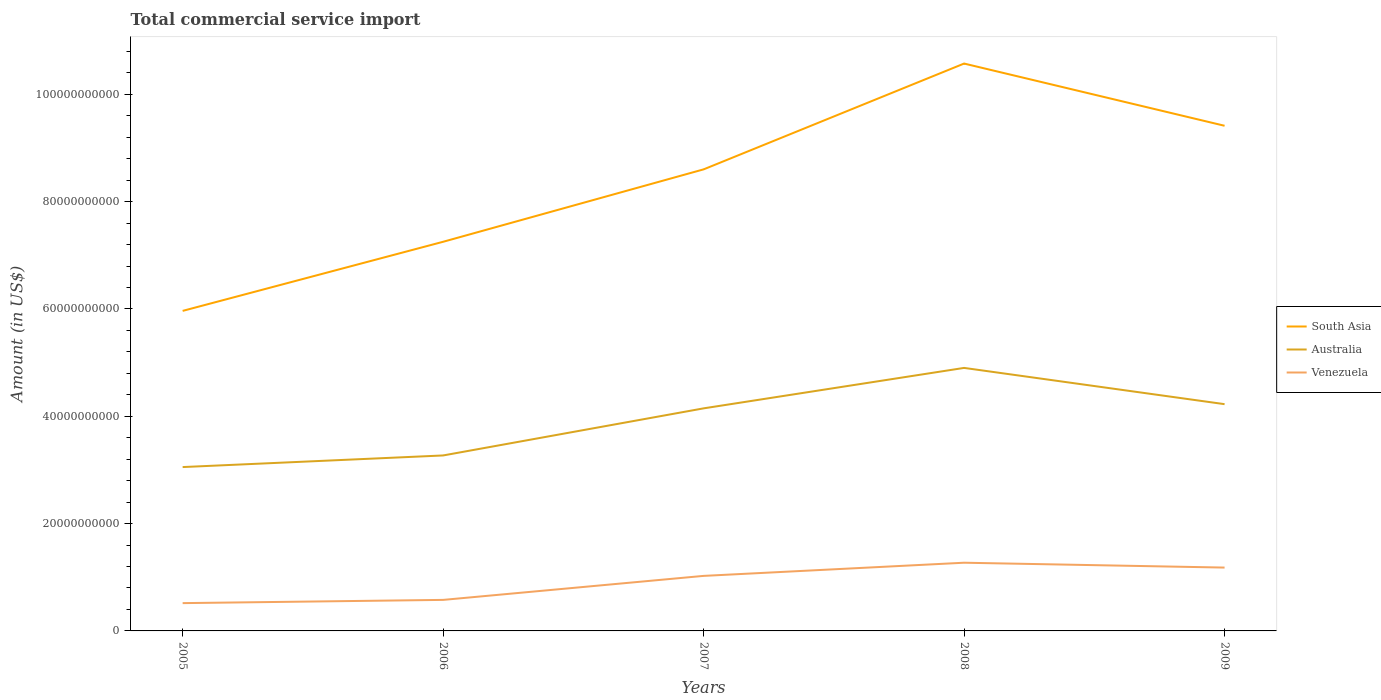How many different coloured lines are there?
Provide a short and direct response. 3. Is the number of lines equal to the number of legend labels?
Provide a succinct answer. Yes. Across all years, what is the maximum total commercial service import in Venezuela?
Give a very brief answer. 5.18e+09. What is the total total commercial service import in Venezuela in the graph?
Provide a short and direct response. -6.03e+08. What is the difference between the highest and the second highest total commercial service import in Venezuela?
Ensure brevity in your answer.  7.53e+09. How many lines are there?
Give a very brief answer. 3. Are the values on the major ticks of Y-axis written in scientific E-notation?
Your answer should be very brief. No. Where does the legend appear in the graph?
Your answer should be compact. Center right. What is the title of the graph?
Provide a short and direct response. Total commercial service import. What is the Amount (in US$) in South Asia in 2005?
Make the answer very short. 5.96e+1. What is the Amount (in US$) in Australia in 2005?
Provide a succinct answer. 3.05e+1. What is the Amount (in US$) of Venezuela in 2005?
Provide a succinct answer. 5.18e+09. What is the Amount (in US$) in South Asia in 2006?
Provide a succinct answer. 7.25e+1. What is the Amount (in US$) in Australia in 2006?
Make the answer very short. 3.27e+1. What is the Amount (in US$) in Venezuela in 2006?
Make the answer very short. 5.78e+09. What is the Amount (in US$) in South Asia in 2007?
Ensure brevity in your answer.  8.60e+1. What is the Amount (in US$) of Australia in 2007?
Your response must be concise. 4.15e+1. What is the Amount (in US$) of Venezuela in 2007?
Make the answer very short. 1.03e+1. What is the Amount (in US$) in South Asia in 2008?
Ensure brevity in your answer.  1.06e+11. What is the Amount (in US$) of Australia in 2008?
Your answer should be very brief. 4.90e+1. What is the Amount (in US$) of Venezuela in 2008?
Provide a succinct answer. 1.27e+1. What is the Amount (in US$) in South Asia in 2009?
Your answer should be compact. 9.41e+1. What is the Amount (in US$) of Australia in 2009?
Your response must be concise. 4.23e+1. What is the Amount (in US$) in Venezuela in 2009?
Keep it short and to the point. 1.18e+1. Across all years, what is the maximum Amount (in US$) of South Asia?
Your answer should be very brief. 1.06e+11. Across all years, what is the maximum Amount (in US$) in Australia?
Provide a short and direct response. 4.90e+1. Across all years, what is the maximum Amount (in US$) of Venezuela?
Your answer should be compact. 1.27e+1. Across all years, what is the minimum Amount (in US$) of South Asia?
Offer a very short reply. 5.96e+1. Across all years, what is the minimum Amount (in US$) in Australia?
Your answer should be compact. 3.05e+1. Across all years, what is the minimum Amount (in US$) in Venezuela?
Your answer should be very brief. 5.18e+09. What is the total Amount (in US$) in South Asia in the graph?
Offer a terse response. 4.18e+11. What is the total Amount (in US$) in Australia in the graph?
Your answer should be compact. 1.96e+11. What is the total Amount (in US$) in Venezuela in the graph?
Give a very brief answer. 4.57e+1. What is the difference between the Amount (in US$) of South Asia in 2005 and that in 2006?
Your response must be concise. -1.29e+1. What is the difference between the Amount (in US$) in Australia in 2005 and that in 2006?
Your answer should be very brief. -2.17e+09. What is the difference between the Amount (in US$) in Venezuela in 2005 and that in 2006?
Give a very brief answer. -6.03e+08. What is the difference between the Amount (in US$) in South Asia in 2005 and that in 2007?
Your answer should be very brief. -2.64e+1. What is the difference between the Amount (in US$) in Australia in 2005 and that in 2007?
Your answer should be compact. -1.09e+1. What is the difference between the Amount (in US$) of Venezuela in 2005 and that in 2007?
Your answer should be compact. -5.08e+09. What is the difference between the Amount (in US$) in South Asia in 2005 and that in 2008?
Provide a short and direct response. -4.61e+1. What is the difference between the Amount (in US$) in Australia in 2005 and that in 2008?
Your response must be concise. -1.85e+1. What is the difference between the Amount (in US$) of Venezuela in 2005 and that in 2008?
Make the answer very short. -7.53e+09. What is the difference between the Amount (in US$) in South Asia in 2005 and that in 2009?
Provide a short and direct response. -3.45e+1. What is the difference between the Amount (in US$) in Australia in 2005 and that in 2009?
Your response must be concise. -1.17e+1. What is the difference between the Amount (in US$) of Venezuela in 2005 and that in 2009?
Offer a terse response. -6.62e+09. What is the difference between the Amount (in US$) in South Asia in 2006 and that in 2007?
Your answer should be compact. -1.35e+1. What is the difference between the Amount (in US$) in Australia in 2006 and that in 2007?
Offer a terse response. -8.78e+09. What is the difference between the Amount (in US$) in Venezuela in 2006 and that in 2007?
Your answer should be compact. -4.47e+09. What is the difference between the Amount (in US$) in South Asia in 2006 and that in 2008?
Offer a terse response. -3.32e+1. What is the difference between the Amount (in US$) in Australia in 2006 and that in 2008?
Offer a terse response. -1.63e+1. What is the difference between the Amount (in US$) of Venezuela in 2006 and that in 2008?
Make the answer very short. -6.93e+09. What is the difference between the Amount (in US$) in South Asia in 2006 and that in 2009?
Offer a very short reply. -2.16e+1. What is the difference between the Amount (in US$) of Australia in 2006 and that in 2009?
Ensure brevity in your answer.  -9.56e+09. What is the difference between the Amount (in US$) of Venezuela in 2006 and that in 2009?
Offer a terse response. -6.02e+09. What is the difference between the Amount (in US$) in South Asia in 2007 and that in 2008?
Provide a succinct answer. -1.97e+1. What is the difference between the Amount (in US$) of Australia in 2007 and that in 2008?
Provide a succinct answer. -7.54e+09. What is the difference between the Amount (in US$) of Venezuela in 2007 and that in 2008?
Provide a succinct answer. -2.45e+09. What is the difference between the Amount (in US$) of South Asia in 2007 and that in 2009?
Offer a very short reply. -8.12e+09. What is the difference between the Amount (in US$) of Australia in 2007 and that in 2009?
Keep it short and to the point. -7.81e+08. What is the difference between the Amount (in US$) in Venezuela in 2007 and that in 2009?
Keep it short and to the point. -1.55e+09. What is the difference between the Amount (in US$) of South Asia in 2008 and that in 2009?
Your response must be concise. 1.16e+1. What is the difference between the Amount (in US$) of Australia in 2008 and that in 2009?
Your answer should be very brief. 6.76e+09. What is the difference between the Amount (in US$) in Venezuela in 2008 and that in 2009?
Provide a short and direct response. 9.05e+08. What is the difference between the Amount (in US$) of South Asia in 2005 and the Amount (in US$) of Australia in 2006?
Provide a short and direct response. 2.69e+1. What is the difference between the Amount (in US$) of South Asia in 2005 and the Amount (in US$) of Venezuela in 2006?
Your response must be concise. 5.39e+1. What is the difference between the Amount (in US$) of Australia in 2005 and the Amount (in US$) of Venezuela in 2006?
Your answer should be compact. 2.48e+1. What is the difference between the Amount (in US$) in South Asia in 2005 and the Amount (in US$) in Australia in 2007?
Make the answer very short. 1.82e+1. What is the difference between the Amount (in US$) in South Asia in 2005 and the Amount (in US$) in Venezuela in 2007?
Give a very brief answer. 4.94e+1. What is the difference between the Amount (in US$) in Australia in 2005 and the Amount (in US$) in Venezuela in 2007?
Your answer should be compact. 2.03e+1. What is the difference between the Amount (in US$) of South Asia in 2005 and the Amount (in US$) of Australia in 2008?
Keep it short and to the point. 1.06e+1. What is the difference between the Amount (in US$) in South Asia in 2005 and the Amount (in US$) in Venezuela in 2008?
Provide a short and direct response. 4.69e+1. What is the difference between the Amount (in US$) in Australia in 2005 and the Amount (in US$) in Venezuela in 2008?
Ensure brevity in your answer.  1.78e+1. What is the difference between the Amount (in US$) of South Asia in 2005 and the Amount (in US$) of Australia in 2009?
Provide a succinct answer. 1.74e+1. What is the difference between the Amount (in US$) of South Asia in 2005 and the Amount (in US$) of Venezuela in 2009?
Give a very brief answer. 4.78e+1. What is the difference between the Amount (in US$) of Australia in 2005 and the Amount (in US$) of Venezuela in 2009?
Your response must be concise. 1.87e+1. What is the difference between the Amount (in US$) of South Asia in 2006 and the Amount (in US$) of Australia in 2007?
Your answer should be compact. 3.10e+1. What is the difference between the Amount (in US$) in South Asia in 2006 and the Amount (in US$) in Venezuela in 2007?
Give a very brief answer. 6.23e+1. What is the difference between the Amount (in US$) in Australia in 2006 and the Amount (in US$) in Venezuela in 2007?
Your answer should be very brief. 2.24e+1. What is the difference between the Amount (in US$) of South Asia in 2006 and the Amount (in US$) of Australia in 2008?
Give a very brief answer. 2.35e+1. What is the difference between the Amount (in US$) in South Asia in 2006 and the Amount (in US$) in Venezuela in 2008?
Your answer should be very brief. 5.98e+1. What is the difference between the Amount (in US$) in Australia in 2006 and the Amount (in US$) in Venezuela in 2008?
Make the answer very short. 2.00e+1. What is the difference between the Amount (in US$) of South Asia in 2006 and the Amount (in US$) of Australia in 2009?
Offer a terse response. 3.03e+1. What is the difference between the Amount (in US$) in South Asia in 2006 and the Amount (in US$) in Venezuela in 2009?
Give a very brief answer. 6.07e+1. What is the difference between the Amount (in US$) in Australia in 2006 and the Amount (in US$) in Venezuela in 2009?
Offer a terse response. 2.09e+1. What is the difference between the Amount (in US$) in South Asia in 2007 and the Amount (in US$) in Australia in 2008?
Provide a short and direct response. 3.70e+1. What is the difference between the Amount (in US$) of South Asia in 2007 and the Amount (in US$) of Venezuela in 2008?
Offer a very short reply. 7.33e+1. What is the difference between the Amount (in US$) in Australia in 2007 and the Amount (in US$) in Venezuela in 2008?
Provide a succinct answer. 2.88e+1. What is the difference between the Amount (in US$) of South Asia in 2007 and the Amount (in US$) of Australia in 2009?
Offer a terse response. 4.38e+1. What is the difference between the Amount (in US$) in South Asia in 2007 and the Amount (in US$) in Venezuela in 2009?
Give a very brief answer. 7.42e+1. What is the difference between the Amount (in US$) in Australia in 2007 and the Amount (in US$) in Venezuela in 2009?
Give a very brief answer. 2.97e+1. What is the difference between the Amount (in US$) in South Asia in 2008 and the Amount (in US$) in Australia in 2009?
Give a very brief answer. 6.35e+1. What is the difference between the Amount (in US$) in South Asia in 2008 and the Amount (in US$) in Venezuela in 2009?
Make the answer very short. 9.39e+1. What is the difference between the Amount (in US$) in Australia in 2008 and the Amount (in US$) in Venezuela in 2009?
Keep it short and to the point. 3.72e+1. What is the average Amount (in US$) of South Asia per year?
Provide a succinct answer. 8.36e+1. What is the average Amount (in US$) in Australia per year?
Your answer should be very brief. 3.92e+1. What is the average Amount (in US$) of Venezuela per year?
Offer a terse response. 9.15e+09. In the year 2005, what is the difference between the Amount (in US$) in South Asia and Amount (in US$) in Australia?
Your response must be concise. 2.91e+1. In the year 2005, what is the difference between the Amount (in US$) in South Asia and Amount (in US$) in Venezuela?
Offer a terse response. 5.45e+1. In the year 2005, what is the difference between the Amount (in US$) of Australia and Amount (in US$) of Venezuela?
Keep it short and to the point. 2.54e+1. In the year 2006, what is the difference between the Amount (in US$) of South Asia and Amount (in US$) of Australia?
Your answer should be very brief. 3.98e+1. In the year 2006, what is the difference between the Amount (in US$) in South Asia and Amount (in US$) in Venezuela?
Make the answer very short. 6.67e+1. In the year 2006, what is the difference between the Amount (in US$) of Australia and Amount (in US$) of Venezuela?
Ensure brevity in your answer.  2.69e+1. In the year 2007, what is the difference between the Amount (in US$) in South Asia and Amount (in US$) in Australia?
Provide a short and direct response. 4.45e+1. In the year 2007, what is the difference between the Amount (in US$) of South Asia and Amount (in US$) of Venezuela?
Provide a succinct answer. 7.58e+1. In the year 2007, what is the difference between the Amount (in US$) of Australia and Amount (in US$) of Venezuela?
Your answer should be compact. 3.12e+1. In the year 2008, what is the difference between the Amount (in US$) of South Asia and Amount (in US$) of Australia?
Ensure brevity in your answer.  5.67e+1. In the year 2008, what is the difference between the Amount (in US$) of South Asia and Amount (in US$) of Venezuela?
Your response must be concise. 9.30e+1. In the year 2008, what is the difference between the Amount (in US$) of Australia and Amount (in US$) of Venezuela?
Offer a terse response. 3.63e+1. In the year 2009, what is the difference between the Amount (in US$) in South Asia and Amount (in US$) in Australia?
Provide a succinct answer. 5.19e+1. In the year 2009, what is the difference between the Amount (in US$) of South Asia and Amount (in US$) of Venezuela?
Give a very brief answer. 8.23e+1. In the year 2009, what is the difference between the Amount (in US$) of Australia and Amount (in US$) of Venezuela?
Your answer should be compact. 3.05e+1. What is the ratio of the Amount (in US$) in South Asia in 2005 to that in 2006?
Provide a succinct answer. 0.82. What is the ratio of the Amount (in US$) of Australia in 2005 to that in 2006?
Offer a very short reply. 0.93. What is the ratio of the Amount (in US$) in Venezuela in 2005 to that in 2006?
Provide a succinct answer. 0.9. What is the ratio of the Amount (in US$) in South Asia in 2005 to that in 2007?
Your response must be concise. 0.69. What is the ratio of the Amount (in US$) of Australia in 2005 to that in 2007?
Your response must be concise. 0.74. What is the ratio of the Amount (in US$) in Venezuela in 2005 to that in 2007?
Your response must be concise. 0.51. What is the ratio of the Amount (in US$) of South Asia in 2005 to that in 2008?
Ensure brevity in your answer.  0.56. What is the ratio of the Amount (in US$) of Australia in 2005 to that in 2008?
Your answer should be very brief. 0.62. What is the ratio of the Amount (in US$) in Venezuela in 2005 to that in 2008?
Offer a very short reply. 0.41. What is the ratio of the Amount (in US$) in South Asia in 2005 to that in 2009?
Provide a short and direct response. 0.63. What is the ratio of the Amount (in US$) in Australia in 2005 to that in 2009?
Ensure brevity in your answer.  0.72. What is the ratio of the Amount (in US$) of Venezuela in 2005 to that in 2009?
Offer a very short reply. 0.44. What is the ratio of the Amount (in US$) in South Asia in 2006 to that in 2007?
Provide a short and direct response. 0.84. What is the ratio of the Amount (in US$) in Australia in 2006 to that in 2007?
Your answer should be compact. 0.79. What is the ratio of the Amount (in US$) in Venezuela in 2006 to that in 2007?
Make the answer very short. 0.56. What is the ratio of the Amount (in US$) in South Asia in 2006 to that in 2008?
Give a very brief answer. 0.69. What is the ratio of the Amount (in US$) of Australia in 2006 to that in 2008?
Offer a very short reply. 0.67. What is the ratio of the Amount (in US$) of Venezuela in 2006 to that in 2008?
Ensure brevity in your answer.  0.46. What is the ratio of the Amount (in US$) of South Asia in 2006 to that in 2009?
Offer a terse response. 0.77. What is the ratio of the Amount (in US$) in Australia in 2006 to that in 2009?
Keep it short and to the point. 0.77. What is the ratio of the Amount (in US$) in Venezuela in 2006 to that in 2009?
Provide a succinct answer. 0.49. What is the ratio of the Amount (in US$) in South Asia in 2007 to that in 2008?
Offer a terse response. 0.81. What is the ratio of the Amount (in US$) in Australia in 2007 to that in 2008?
Offer a very short reply. 0.85. What is the ratio of the Amount (in US$) of Venezuela in 2007 to that in 2008?
Provide a succinct answer. 0.81. What is the ratio of the Amount (in US$) in South Asia in 2007 to that in 2009?
Provide a short and direct response. 0.91. What is the ratio of the Amount (in US$) in Australia in 2007 to that in 2009?
Ensure brevity in your answer.  0.98. What is the ratio of the Amount (in US$) of Venezuela in 2007 to that in 2009?
Provide a short and direct response. 0.87. What is the ratio of the Amount (in US$) of South Asia in 2008 to that in 2009?
Your response must be concise. 1.12. What is the ratio of the Amount (in US$) of Australia in 2008 to that in 2009?
Give a very brief answer. 1.16. What is the ratio of the Amount (in US$) of Venezuela in 2008 to that in 2009?
Give a very brief answer. 1.08. What is the difference between the highest and the second highest Amount (in US$) in South Asia?
Offer a very short reply. 1.16e+1. What is the difference between the highest and the second highest Amount (in US$) of Australia?
Keep it short and to the point. 6.76e+09. What is the difference between the highest and the second highest Amount (in US$) of Venezuela?
Your answer should be compact. 9.05e+08. What is the difference between the highest and the lowest Amount (in US$) in South Asia?
Provide a short and direct response. 4.61e+1. What is the difference between the highest and the lowest Amount (in US$) of Australia?
Provide a succinct answer. 1.85e+1. What is the difference between the highest and the lowest Amount (in US$) in Venezuela?
Keep it short and to the point. 7.53e+09. 